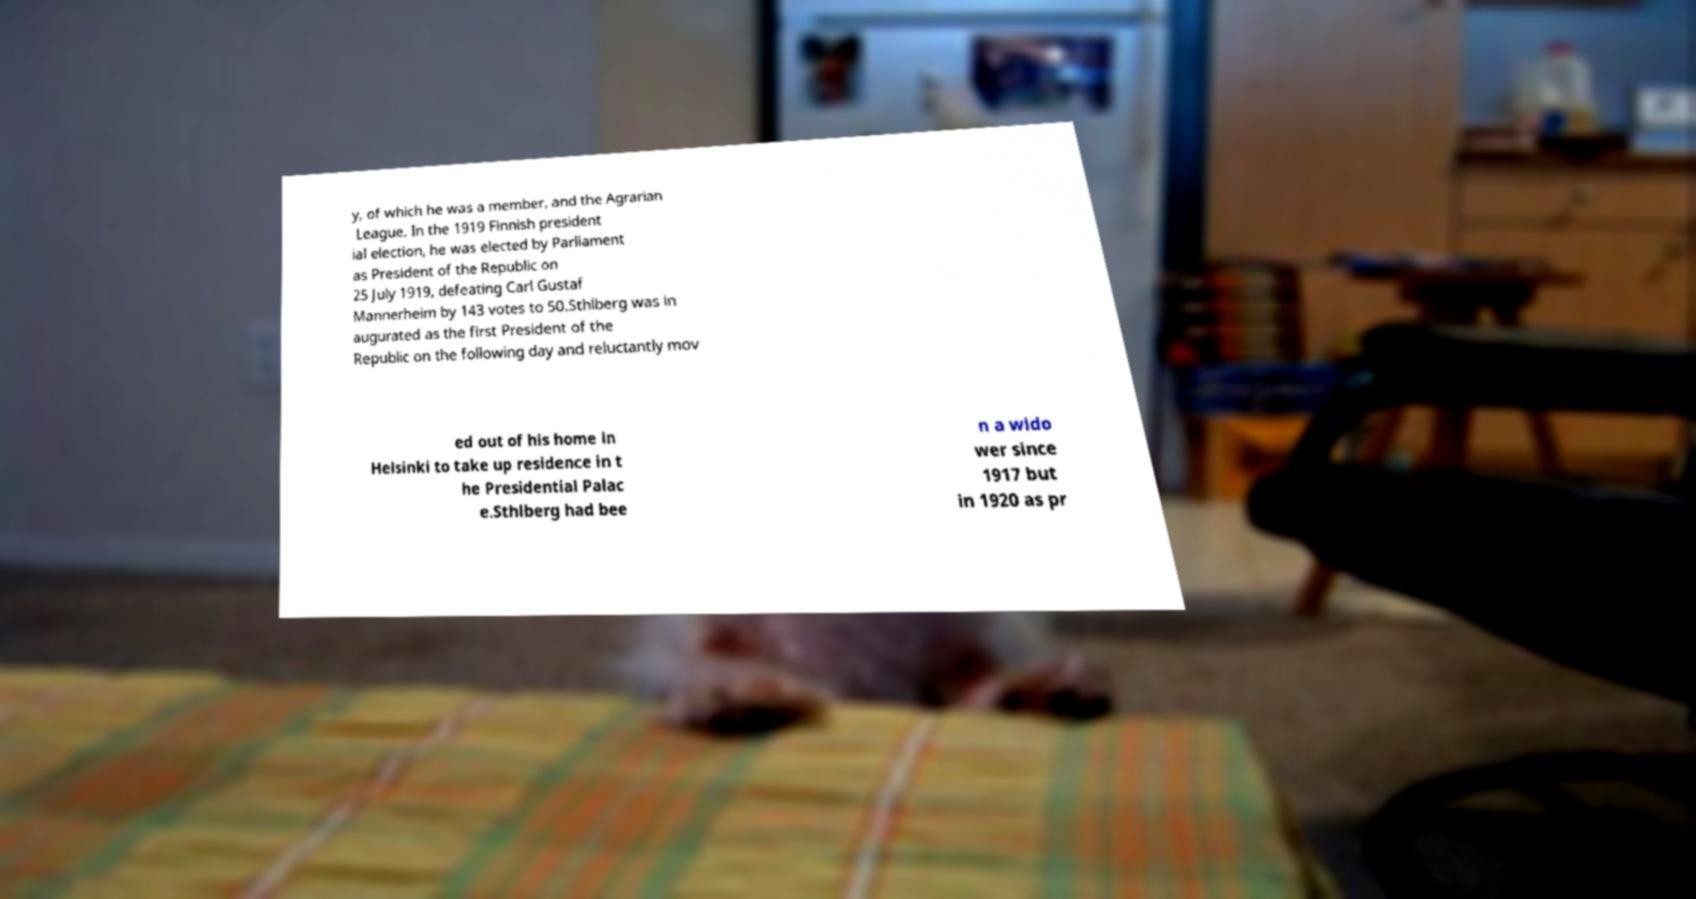I need the written content from this picture converted into text. Can you do that? y, of which he was a member, and the Agrarian League. In the 1919 Finnish president ial election, he was elected by Parliament as President of the Republic on 25 July 1919, defeating Carl Gustaf Mannerheim by 143 votes to 50.Sthlberg was in augurated as the first President of the Republic on the following day and reluctantly mov ed out of his home in Helsinki to take up residence in t he Presidential Palac e.Sthlberg had bee n a wido wer since 1917 but in 1920 as pr 